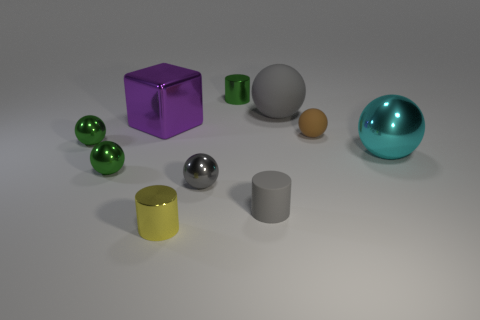What material is the big sphere on the left side of the small brown rubber object?
Your answer should be very brief. Rubber. What is the color of the large sphere that is made of the same material as the purple cube?
Provide a succinct answer. Cyan. How many green objects have the same size as the green cylinder?
Make the answer very short. 2. There is a green ball that is behind the cyan metallic object; is it the same size as the purple object?
Your response must be concise. No. There is a object that is both behind the big metallic block and left of the big gray matte object; what shape is it?
Give a very brief answer. Cylinder. Are there any blocks behind the small green cylinder?
Your answer should be very brief. No. Is there any other thing that has the same shape as the large purple shiny object?
Your answer should be compact. No. Is the shape of the large cyan metallic object the same as the big purple shiny thing?
Ensure brevity in your answer.  No. Are there an equal number of balls that are to the right of the large purple object and gray cylinders left of the green cylinder?
Ensure brevity in your answer.  No. What number of other things are the same material as the large cyan ball?
Offer a very short reply. 6. 